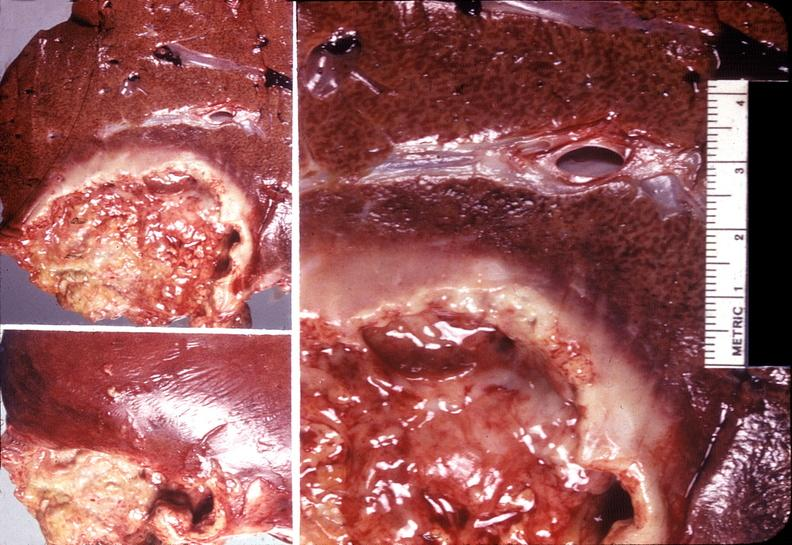what is present?
Answer the question using a single word or phrase. Hepatobiliary 